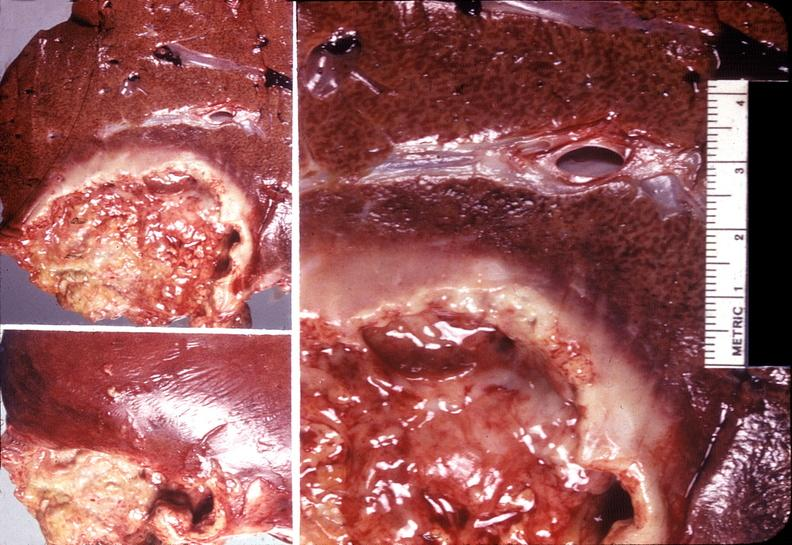what is present?
Answer the question using a single word or phrase. Hepatobiliary 